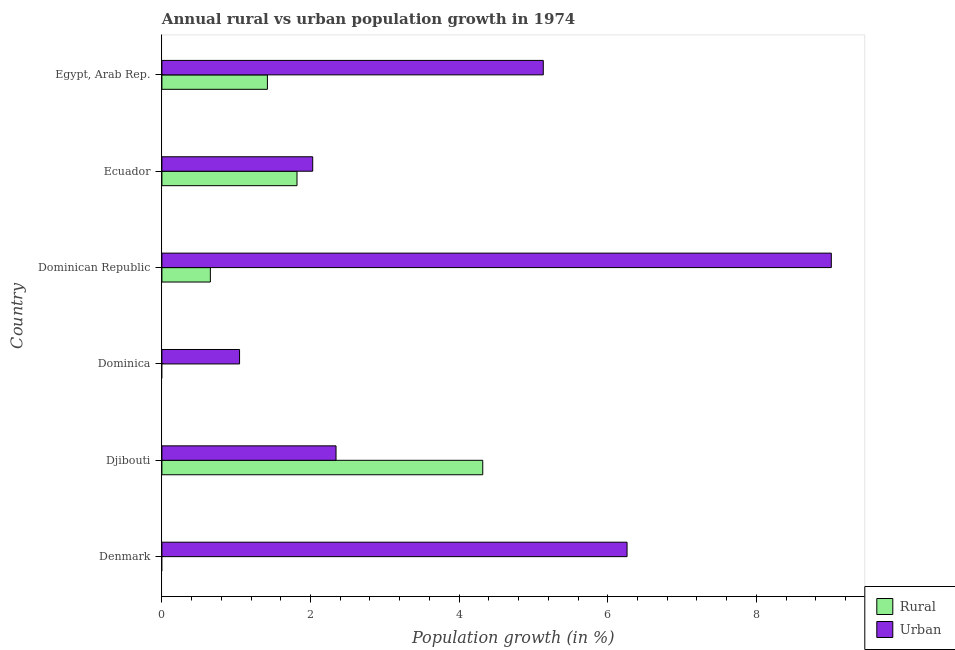Are the number of bars per tick equal to the number of legend labels?
Your answer should be compact. No. How many bars are there on the 3rd tick from the bottom?
Give a very brief answer. 1. What is the label of the 3rd group of bars from the top?
Ensure brevity in your answer.  Dominican Republic. In how many cases, is the number of bars for a given country not equal to the number of legend labels?
Make the answer very short. 2. Across all countries, what is the maximum urban population growth?
Keep it short and to the point. 9.01. Across all countries, what is the minimum urban population growth?
Give a very brief answer. 1.05. In which country was the urban population growth maximum?
Your answer should be very brief. Dominican Republic. What is the total urban population growth in the graph?
Make the answer very short. 25.82. What is the difference between the urban population growth in Ecuador and that in Egypt, Arab Rep.?
Keep it short and to the point. -3.1. What is the difference between the rural population growth in Egypt, Arab Rep. and the urban population growth in Djibouti?
Give a very brief answer. -0.92. What is the average rural population growth per country?
Give a very brief answer. 1.37. What is the difference between the rural population growth and urban population growth in Ecuador?
Offer a very short reply. -0.21. What is the ratio of the urban population growth in Dominican Republic to that in Egypt, Arab Rep.?
Provide a succinct answer. 1.75. Is the urban population growth in Denmark less than that in Dominica?
Your answer should be compact. No. What is the difference between the highest and the second highest rural population growth?
Offer a terse response. 2.5. What is the difference between the highest and the lowest rural population growth?
Your answer should be compact. 4.32. How many bars are there?
Offer a terse response. 10. Are the values on the major ticks of X-axis written in scientific E-notation?
Your response must be concise. No. Does the graph contain any zero values?
Offer a terse response. Yes. How many legend labels are there?
Make the answer very short. 2. How are the legend labels stacked?
Give a very brief answer. Vertical. What is the title of the graph?
Your answer should be very brief. Annual rural vs urban population growth in 1974. What is the label or title of the X-axis?
Offer a terse response. Population growth (in %). What is the Population growth (in %) in Urban  in Denmark?
Keep it short and to the point. 6.26. What is the Population growth (in %) of Rural in Djibouti?
Your answer should be very brief. 4.32. What is the Population growth (in %) in Urban  in Djibouti?
Ensure brevity in your answer.  2.34. What is the Population growth (in %) of Urban  in Dominica?
Provide a succinct answer. 1.05. What is the Population growth (in %) in Rural in Dominican Republic?
Ensure brevity in your answer.  0.65. What is the Population growth (in %) of Urban  in Dominican Republic?
Offer a terse response. 9.01. What is the Population growth (in %) of Rural in Ecuador?
Keep it short and to the point. 1.82. What is the Population growth (in %) of Urban  in Ecuador?
Offer a terse response. 2.03. What is the Population growth (in %) of Rural in Egypt, Arab Rep.?
Give a very brief answer. 1.42. What is the Population growth (in %) in Urban  in Egypt, Arab Rep.?
Provide a succinct answer. 5.13. Across all countries, what is the maximum Population growth (in %) of Rural?
Give a very brief answer. 4.32. Across all countries, what is the maximum Population growth (in %) of Urban ?
Your answer should be very brief. 9.01. Across all countries, what is the minimum Population growth (in %) of Urban ?
Your answer should be very brief. 1.05. What is the total Population growth (in %) in Rural in the graph?
Provide a succinct answer. 8.21. What is the total Population growth (in %) of Urban  in the graph?
Ensure brevity in your answer.  25.82. What is the difference between the Population growth (in %) of Urban  in Denmark and that in Djibouti?
Your response must be concise. 3.92. What is the difference between the Population growth (in %) of Urban  in Denmark and that in Dominica?
Make the answer very short. 5.21. What is the difference between the Population growth (in %) of Urban  in Denmark and that in Dominican Republic?
Keep it short and to the point. -2.75. What is the difference between the Population growth (in %) of Urban  in Denmark and that in Ecuador?
Provide a short and direct response. 4.23. What is the difference between the Population growth (in %) of Urban  in Denmark and that in Egypt, Arab Rep.?
Give a very brief answer. 1.13. What is the difference between the Population growth (in %) in Urban  in Djibouti and that in Dominica?
Offer a terse response. 1.3. What is the difference between the Population growth (in %) of Rural in Djibouti and that in Dominican Republic?
Your answer should be very brief. 3.67. What is the difference between the Population growth (in %) of Urban  in Djibouti and that in Dominican Republic?
Make the answer very short. -6.67. What is the difference between the Population growth (in %) of Rural in Djibouti and that in Ecuador?
Provide a succinct answer. 2.5. What is the difference between the Population growth (in %) of Urban  in Djibouti and that in Ecuador?
Your answer should be very brief. 0.31. What is the difference between the Population growth (in %) in Rural in Djibouti and that in Egypt, Arab Rep.?
Your answer should be very brief. 2.9. What is the difference between the Population growth (in %) in Urban  in Djibouti and that in Egypt, Arab Rep.?
Your response must be concise. -2.79. What is the difference between the Population growth (in %) of Urban  in Dominica and that in Dominican Republic?
Your answer should be very brief. -7.96. What is the difference between the Population growth (in %) of Urban  in Dominica and that in Ecuador?
Provide a succinct answer. -0.98. What is the difference between the Population growth (in %) in Urban  in Dominica and that in Egypt, Arab Rep.?
Give a very brief answer. -4.09. What is the difference between the Population growth (in %) in Rural in Dominican Republic and that in Ecuador?
Your answer should be very brief. -1.17. What is the difference between the Population growth (in %) in Urban  in Dominican Republic and that in Ecuador?
Ensure brevity in your answer.  6.98. What is the difference between the Population growth (in %) in Rural in Dominican Republic and that in Egypt, Arab Rep.?
Keep it short and to the point. -0.77. What is the difference between the Population growth (in %) of Urban  in Dominican Republic and that in Egypt, Arab Rep.?
Offer a very short reply. 3.88. What is the difference between the Population growth (in %) of Rural in Ecuador and that in Egypt, Arab Rep.?
Make the answer very short. 0.4. What is the difference between the Population growth (in %) in Urban  in Ecuador and that in Egypt, Arab Rep.?
Your response must be concise. -3.1. What is the difference between the Population growth (in %) in Rural in Djibouti and the Population growth (in %) in Urban  in Dominica?
Your answer should be compact. 3.27. What is the difference between the Population growth (in %) of Rural in Djibouti and the Population growth (in %) of Urban  in Dominican Republic?
Give a very brief answer. -4.69. What is the difference between the Population growth (in %) in Rural in Djibouti and the Population growth (in %) in Urban  in Ecuador?
Offer a terse response. 2.29. What is the difference between the Population growth (in %) in Rural in Djibouti and the Population growth (in %) in Urban  in Egypt, Arab Rep.?
Offer a terse response. -0.81. What is the difference between the Population growth (in %) of Rural in Dominican Republic and the Population growth (in %) of Urban  in Ecuador?
Ensure brevity in your answer.  -1.38. What is the difference between the Population growth (in %) of Rural in Dominican Republic and the Population growth (in %) of Urban  in Egypt, Arab Rep.?
Give a very brief answer. -4.48. What is the difference between the Population growth (in %) in Rural in Ecuador and the Population growth (in %) in Urban  in Egypt, Arab Rep.?
Make the answer very short. -3.31. What is the average Population growth (in %) in Rural per country?
Offer a very short reply. 1.37. What is the average Population growth (in %) in Urban  per country?
Make the answer very short. 4.3. What is the difference between the Population growth (in %) of Rural and Population growth (in %) of Urban  in Djibouti?
Ensure brevity in your answer.  1.97. What is the difference between the Population growth (in %) in Rural and Population growth (in %) in Urban  in Dominican Republic?
Offer a terse response. -8.36. What is the difference between the Population growth (in %) in Rural and Population growth (in %) in Urban  in Ecuador?
Give a very brief answer. -0.21. What is the difference between the Population growth (in %) in Rural and Population growth (in %) in Urban  in Egypt, Arab Rep.?
Your answer should be very brief. -3.71. What is the ratio of the Population growth (in %) in Urban  in Denmark to that in Djibouti?
Offer a terse response. 2.67. What is the ratio of the Population growth (in %) of Urban  in Denmark to that in Dominica?
Your answer should be very brief. 5.99. What is the ratio of the Population growth (in %) in Urban  in Denmark to that in Dominican Republic?
Your answer should be compact. 0.69. What is the ratio of the Population growth (in %) in Urban  in Denmark to that in Ecuador?
Your answer should be compact. 3.08. What is the ratio of the Population growth (in %) of Urban  in Denmark to that in Egypt, Arab Rep.?
Make the answer very short. 1.22. What is the ratio of the Population growth (in %) in Urban  in Djibouti to that in Dominica?
Give a very brief answer. 2.24. What is the ratio of the Population growth (in %) in Rural in Djibouti to that in Dominican Republic?
Offer a terse response. 6.62. What is the ratio of the Population growth (in %) of Urban  in Djibouti to that in Dominican Republic?
Provide a short and direct response. 0.26. What is the ratio of the Population growth (in %) in Rural in Djibouti to that in Ecuador?
Provide a succinct answer. 2.37. What is the ratio of the Population growth (in %) in Urban  in Djibouti to that in Ecuador?
Your answer should be very brief. 1.15. What is the ratio of the Population growth (in %) of Rural in Djibouti to that in Egypt, Arab Rep.?
Provide a short and direct response. 3.04. What is the ratio of the Population growth (in %) in Urban  in Djibouti to that in Egypt, Arab Rep.?
Keep it short and to the point. 0.46. What is the ratio of the Population growth (in %) in Urban  in Dominica to that in Dominican Republic?
Your response must be concise. 0.12. What is the ratio of the Population growth (in %) of Urban  in Dominica to that in Ecuador?
Offer a very short reply. 0.51. What is the ratio of the Population growth (in %) of Urban  in Dominica to that in Egypt, Arab Rep.?
Offer a very short reply. 0.2. What is the ratio of the Population growth (in %) in Rural in Dominican Republic to that in Ecuador?
Your answer should be compact. 0.36. What is the ratio of the Population growth (in %) of Urban  in Dominican Republic to that in Ecuador?
Your response must be concise. 4.44. What is the ratio of the Population growth (in %) of Rural in Dominican Republic to that in Egypt, Arab Rep.?
Make the answer very short. 0.46. What is the ratio of the Population growth (in %) of Urban  in Dominican Republic to that in Egypt, Arab Rep.?
Your answer should be very brief. 1.76. What is the ratio of the Population growth (in %) of Rural in Ecuador to that in Egypt, Arab Rep.?
Ensure brevity in your answer.  1.28. What is the ratio of the Population growth (in %) of Urban  in Ecuador to that in Egypt, Arab Rep.?
Offer a very short reply. 0.4. What is the difference between the highest and the second highest Population growth (in %) in Rural?
Provide a succinct answer. 2.5. What is the difference between the highest and the second highest Population growth (in %) of Urban ?
Your answer should be compact. 2.75. What is the difference between the highest and the lowest Population growth (in %) of Rural?
Your answer should be very brief. 4.32. What is the difference between the highest and the lowest Population growth (in %) in Urban ?
Ensure brevity in your answer.  7.96. 